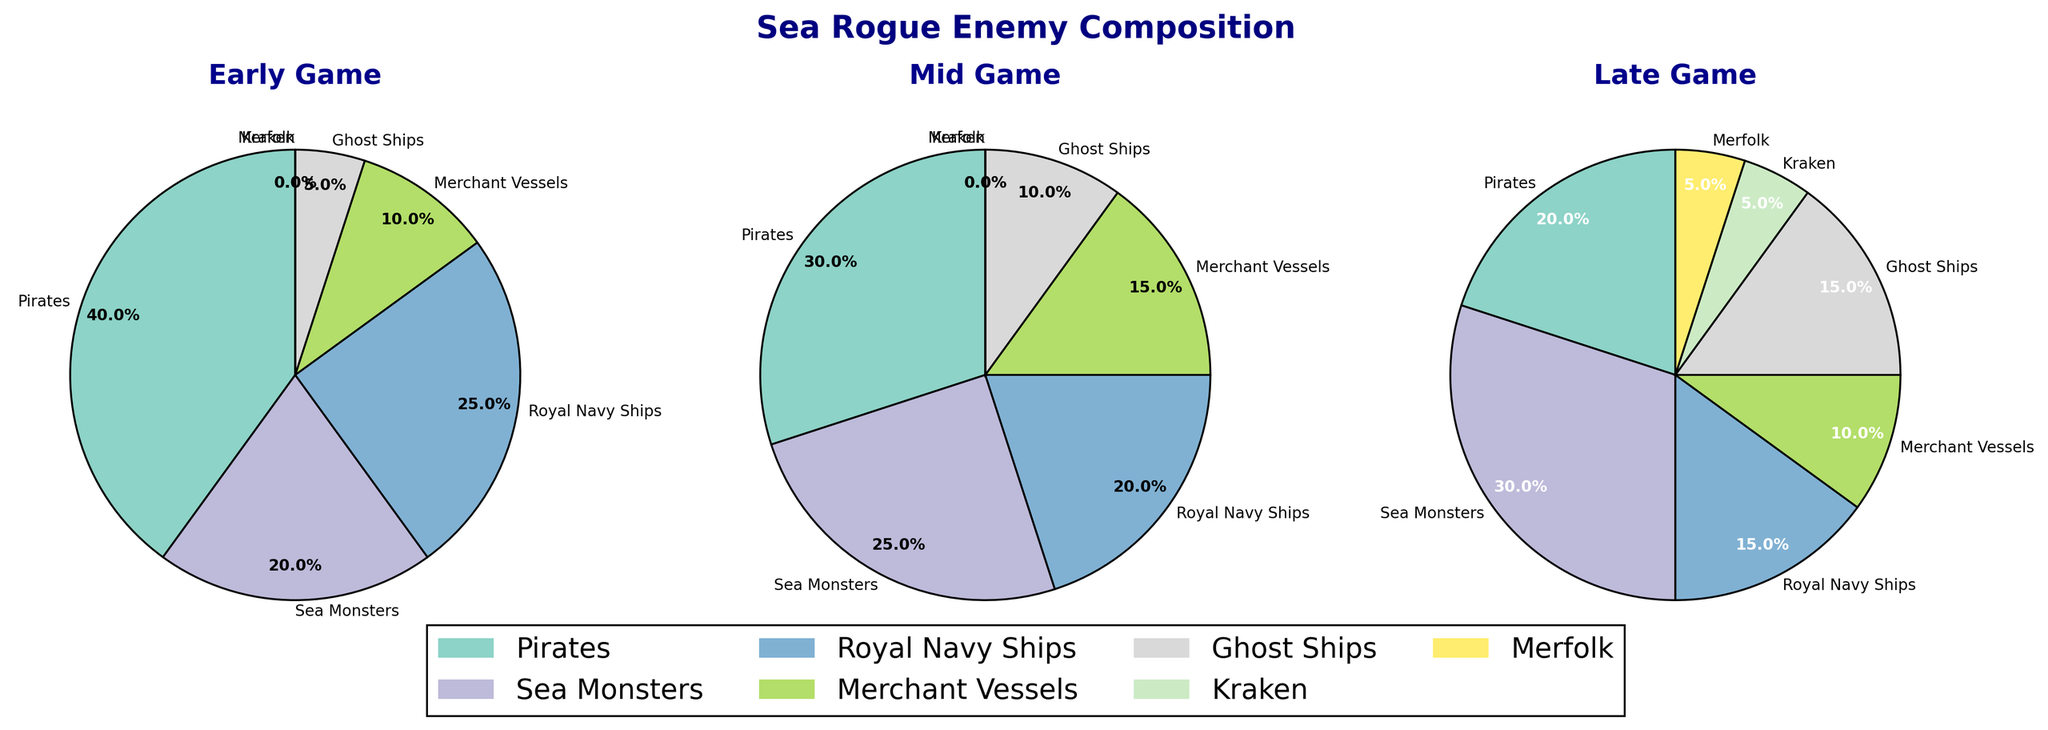Which enemy type increases the most from Early Game to Late Game? Look at the percentages of each enemy type in both the Early Game and Late Game subplots. Calculate the difference for each type: Pirates (20% decrease), Sea Monsters (10% increase), Royal Navy Ships (10% decrease), Merchant Vessels (no change), Ghost Ships (10% increase), Kraken (5% increase), Merfolk (5% increase). The type with the highest increase is Sea Monsters.
Answer: Sea Monsters What is the total percentage of Ghost Ships encountered in the Mid Game and Late Game combined? Find the percentages for Ghost Ships in both the Mid Game and Late Game subplots: Mid Game (10%), Late Game (15%). Sum these percentages: 10% + 15% = 25%.
Answer: 25% Which phase has the highest percentage of Sea Monsters? Compare the percentage of Sea Monsters in the Early Game, Mid Game, and Late Game subplots: Early Game (20%), Mid Game (25%), Late Game (30%). The phase with the highest percentage is the Late Game.
Answer: Late Game How does the percentage of Pirates change from Early Game to Mid Game, and then to Late Game? Look at the percentages of Pirates in each subplot: Early Game (40%), Mid Game (30%), Late Game (20%). Calculate the differences: Early to Mid Game (10% decrease), Mid to Late Game (10% decrease). Overall, Pirates decrease by 20%.
Answer: Decreases by 20% Which enemy type is only encountered in the Late Game? Look at the Late Game subplot and identify the enemy types that appear with non-zero percentages only in this phase: Kraken (5%) and Merfolk (5%).
Answer: Kraken and Merfolk What's the difference in percentage of Royal Navy Ships between Early Game and Late Game? Find the percentages for Royal Navy Ships in the Early Game and Late Game subplots: Early Game (25%), Late Game (15%). Calculate the difference: 25% - 15% = 10%.
Answer: 10% Which enemy type has the same percentage in the Early Game and Late Game? Compare the percentages for each enemy type in the Early Game and Late Game subplots. Merchant Vessels have 10% in both phases.
Answer: Merchant Vessels How does the composition of Merchant Vessels compare from Early Game to Mid Game? Look at the percentages of Merchant Vessels in the Early Game and Mid Game subplots: Early Game (10%), Mid Game (15%). Merchant Vessels increase by 5% in the Mid Game.
Answer: Increases by 5% What is the combined percentage of Kraken and Merfolk in the Late Game? Find the percentages for Kraken (5%) and Merfolk (5%) in the Late Game subplot. Sum these percentages: 5% + 5% = 10%.
Answer: 10% What color represents Ghost Ships in the plots? Look at the legend in the figure, where colors and corresponding enemy types are listed. Identify the color associated with Ghost Ships. (While the exact color name isn't provided in the data, one can inspect the legend on the plot for the color).
Answer: (Color) from legend 